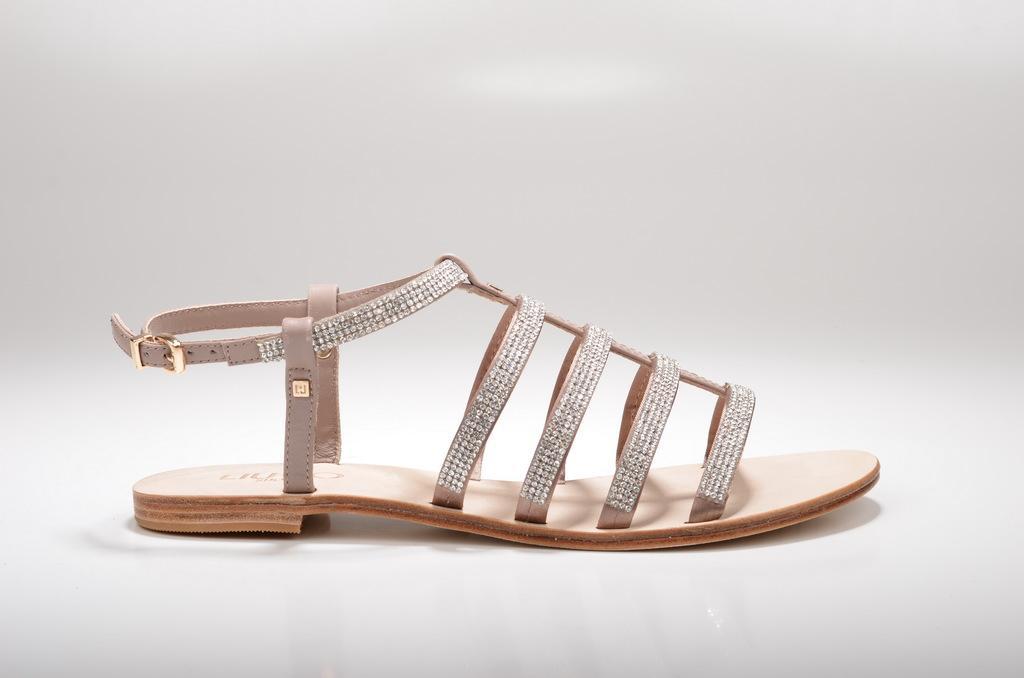In one or two sentences, can you explain what this image depicts? In this picture we can see a sandal and in the background it is in white color. 